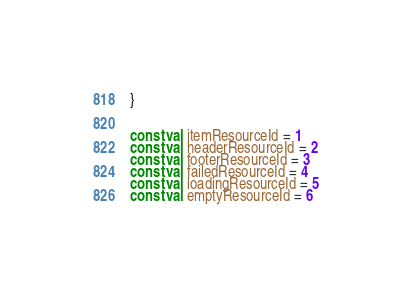Convert code to text. <code><loc_0><loc_0><loc_500><loc_500><_Kotlin_>}


const val itemResourceId = 1
const val headerResourceId = 2
const val footerResourceId = 3
const val failedResourceId = 4
const val loadingResourceId = 5
const val emptyResourceId = 6</code> 